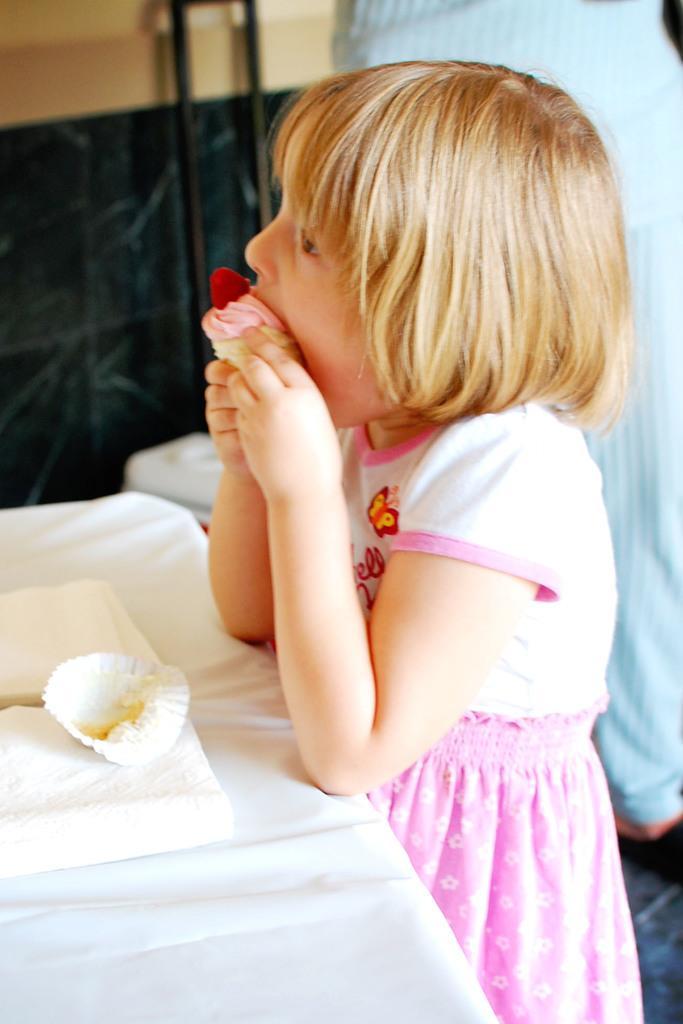How would you summarize this image in a sentence or two? Here I can see a girl standing facing towards the left side and eating cake. In front of her there is a table which is covered with a white color cloth. On the table, I can see a white color object and a cupcake wrapper. At the back of this girl there is another person. In the background there is a wall and two metal rods. 